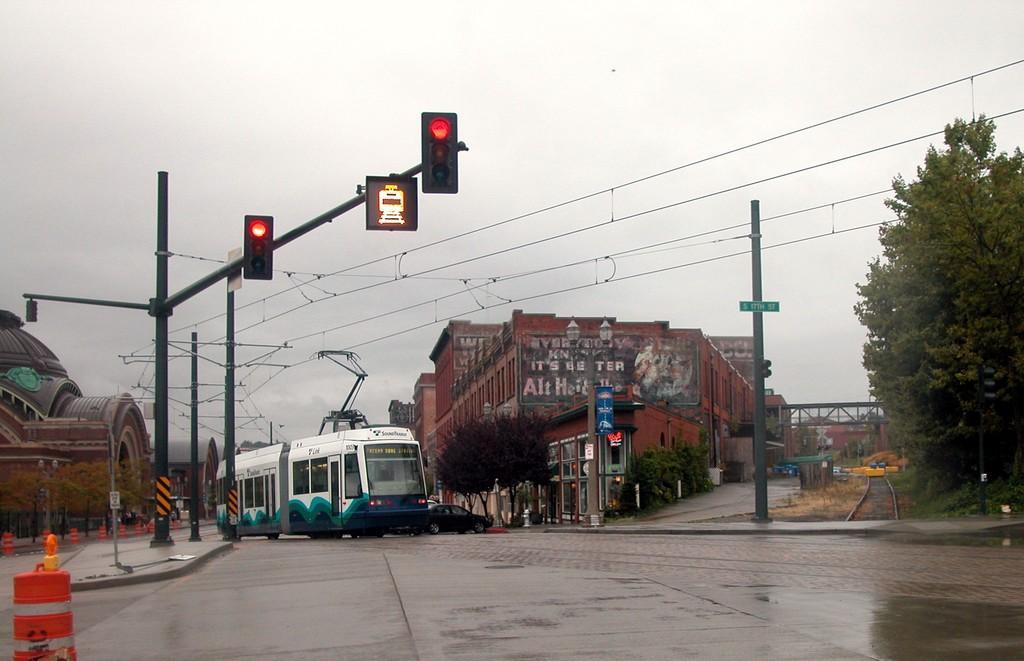In one or two sentences, can you explain what this image depicts? In this image, there is a bus, some vehicles and there are traffic cones on the road and in the background, we can see trees, poles along with wires, traffic lights and some buildings are there. 